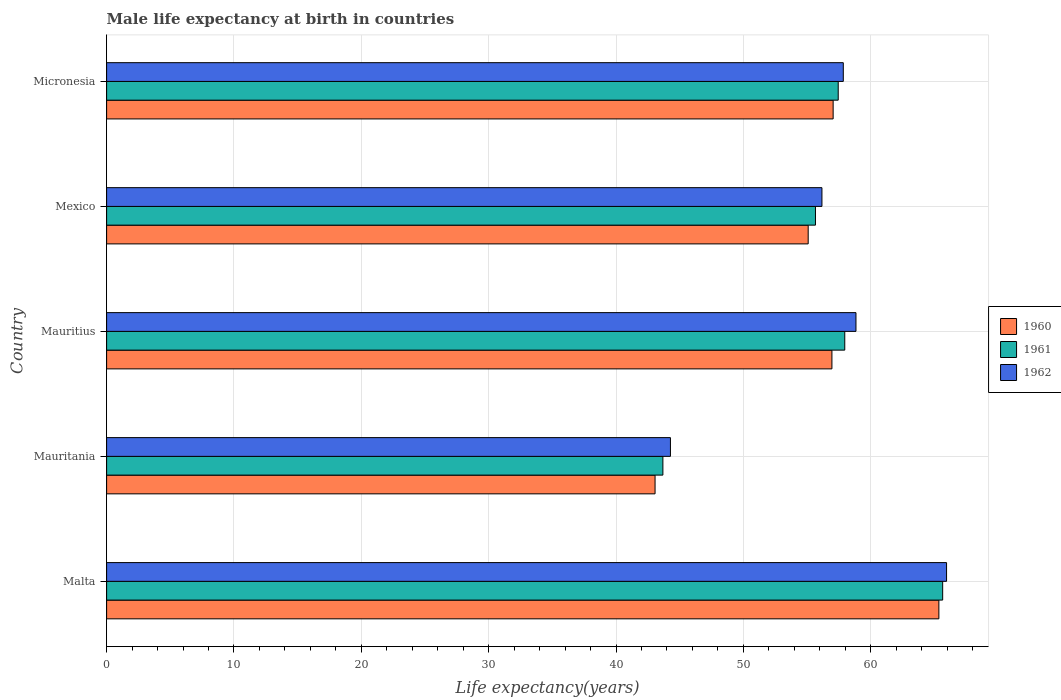How many groups of bars are there?
Ensure brevity in your answer.  5. Are the number of bars per tick equal to the number of legend labels?
Give a very brief answer. Yes. Are the number of bars on each tick of the Y-axis equal?
Your answer should be very brief. Yes. How many bars are there on the 4th tick from the top?
Your answer should be very brief. 3. What is the label of the 2nd group of bars from the top?
Ensure brevity in your answer.  Mexico. In how many cases, is the number of bars for a given country not equal to the number of legend labels?
Offer a terse response. 0. What is the male life expectancy at birth in 1962 in Mauritius?
Your response must be concise. 58.84. Across all countries, what is the maximum male life expectancy at birth in 1960?
Make the answer very short. 65.35. Across all countries, what is the minimum male life expectancy at birth in 1960?
Offer a terse response. 43.07. In which country was the male life expectancy at birth in 1962 maximum?
Provide a short and direct response. Malta. In which country was the male life expectancy at birth in 1961 minimum?
Your answer should be compact. Mauritania. What is the total male life expectancy at birth in 1962 in the graph?
Give a very brief answer. 283.09. What is the difference between the male life expectancy at birth in 1960 in Mauritius and that in Mexico?
Make the answer very short. 1.86. What is the difference between the male life expectancy at birth in 1962 in Mauritania and the male life expectancy at birth in 1960 in Malta?
Ensure brevity in your answer.  -21.08. What is the average male life expectancy at birth in 1960 per country?
Provide a short and direct response. 55.5. What is the difference between the male life expectancy at birth in 1961 and male life expectancy at birth in 1960 in Mexico?
Provide a short and direct response. 0.57. What is the ratio of the male life expectancy at birth in 1961 in Mauritius to that in Mexico?
Keep it short and to the point. 1.04. What is the difference between the highest and the second highest male life expectancy at birth in 1962?
Offer a terse response. 7.11. What is the difference between the highest and the lowest male life expectancy at birth in 1961?
Give a very brief answer. 21.97. In how many countries, is the male life expectancy at birth in 1962 greater than the average male life expectancy at birth in 1962 taken over all countries?
Offer a very short reply. 3. Is the sum of the male life expectancy at birth in 1961 in Mauritius and Mexico greater than the maximum male life expectancy at birth in 1962 across all countries?
Make the answer very short. Yes. How many bars are there?
Your answer should be very brief. 15. What is the difference between two consecutive major ticks on the X-axis?
Offer a terse response. 10. Where does the legend appear in the graph?
Provide a succinct answer. Center right. How are the legend labels stacked?
Provide a short and direct response. Vertical. What is the title of the graph?
Give a very brief answer. Male life expectancy at birth in countries. Does "1969" appear as one of the legend labels in the graph?
Ensure brevity in your answer.  No. What is the label or title of the X-axis?
Keep it short and to the point. Life expectancy(years). What is the label or title of the Y-axis?
Ensure brevity in your answer.  Country. What is the Life expectancy(years) of 1960 in Malta?
Offer a terse response. 65.35. What is the Life expectancy(years) of 1961 in Malta?
Give a very brief answer. 65.65. What is the Life expectancy(years) in 1962 in Malta?
Your answer should be compact. 65.96. What is the Life expectancy(years) of 1960 in Mauritania?
Your response must be concise. 43.07. What is the Life expectancy(years) in 1961 in Mauritania?
Give a very brief answer. 43.68. What is the Life expectancy(years) in 1962 in Mauritania?
Ensure brevity in your answer.  44.27. What is the Life expectancy(years) in 1960 in Mauritius?
Offer a very short reply. 56.95. What is the Life expectancy(years) of 1961 in Mauritius?
Offer a very short reply. 57.96. What is the Life expectancy(years) of 1962 in Mauritius?
Your response must be concise. 58.84. What is the Life expectancy(years) in 1960 in Mexico?
Your answer should be very brief. 55.09. What is the Life expectancy(years) of 1961 in Mexico?
Keep it short and to the point. 55.66. What is the Life expectancy(years) of 1962 in Mexico?
Your answer should be compact. 56.17. What is the Life expectancy(years) of 1960 in Micronesia?
Provide a short and direct response. 57.05. What is the Life expectancy(years) in 1961 in Micronesia?
Ensure brevity in your answer.  57.45. What is the Life expectancy(years) of 1962 in Micronesia?
Offer a very short reply. 57.85. Across all countries, what is the maximum Life expectancy(years) in 1960?
Offer a terse response. 65.35. Across all countries, what is the maximum Life expectancy(years) in 1961?
Offer a terse response. 65.65. Across all countries, what is the maximum Life expectancy(years) of 1962?
Your response must be concise. 65.96. Across all countries, what is the minimum Life expectancy(years) of 1960?
Give a very brief answer. 43.07. Across all countries, what is the minimum Life expectancy(years) in 1961?
Provide a succinct answer. 43.68. Across all countries, what is the minimum Life expectancy(years) of 1962?
Keep it short and to the point. 44.27. What is the total Life expectancy(years) in 1960 in the graph?
Keep it short and to the point. 277.51. What is the total Life expectancy(years) of 1961 in the graph?
Keep it short and to the point. 280.41. What is the total Life expectancy(years) of 1962 in the graph?
Your response must be concise. 283.09. What is the difference between the Life expectancy(years) of 1960 in Malta and that in Mauritania?
Give a very brief answer. 22.29. What is the difference between the Life expectancy(years) of 1961 in Malta and that in Mauritania?
Ensure brevity in your answer.  21.97. What is the difference between the Life expectancy(years) in 1962 in Malta and that in Mauritania?
Offer a terse response. 21.68. What is the difference between the Life expectancy(years) of 1960 in Malta and that in Mauritius?
Offer a terse response. 8.4. What is the difference between the Life expectancy(years) of 1961 in Malta and that in Mauritius?
Make the answer very short. 7.69. What is the difference between the Life expectancy(years) of 1962 in Malta and that in Mauritius?
Ensure brevity in your answer.  7.11. What is the difference between the Life expectancy(years) in 1960 in Malta and that in Mexico?
Your answer should be very brief. 10.26. What is the difference between the Life expectancy(years) in 1961 in Malta and that in Mexico?
Give a very brief answer. 9.99. What is the difference between the Life expectancy(years) of 1962 in Malta and that in Mexico?
Your response must be concise. 9.79. What is the difference between the Life expectancy(years) in 1960 in Malta and that in Micronesia?
Provide a short and direct response. 8.3. What is the difference between the Life expectancy(years) in 1961 in Malta and that in Micronesia?
Your answer should be very brief. 8.2. What is the difference between the Life expectancy(years) of 1962 in Malta and that in Micronesia?
Provide a succinct answer. 8.11. What is the difference between the Life expectancy(years) in 1960 in Mauritania and that in Mauritius?
Make the answer very short. -13.89. What is the difference between the Life expectancy(years) of 1961 in Mauritania and that in Mauritius?
Provide a short and direct response. -14.28. What is the difference between the Life expectancy(years) of 1962 in Mauritania and that in Mauritius?
Offer a very short reply. -14.57. What is the difference between the Life expectancy(years) of 1960 in Mauritania and that in Mexico?
Your response must be concise. -12.02. What is the difference between the Life expectancy(years) of 1961 in Mauritania and that in Mexico?
Keep it short and to the point. -11.98. What is the difference between the Life expectancy(years) in 1962 in Mauritania and that in Mexico?
Offer a terse response. -11.9. What is the difference between the Life expectancy(years) in 1960 in Mauritania and that in Micronesia?
Provide a succinct answer. -13.98. What is the difference between the Life expectancy(years) in 1961 in Mauritania and that in Micronesia?
Ensure brevity in your answer.  -13.77. What is the difference between the Life expectancy(years) in 1962 in Mauritania and that in Micronesia?
Your answer should be compact. -13.57. What is the difference between the Life expectancy(years) in 1960 in Mauritius and that in Mexico?
Keep it short and to the point. 1.86. What is the difference between the Life expectancy(years) of 1961 in Mauritius and that in Mexico?
Give a very brief answer. 2.3. What is the difference between the Life expectancy(years) of 1962 in Mauritius and that in Mexico?
Offer a terse response. 2.67. What is the difference between the Life expectancy(years) of 1960 in Mauritius and that in Micronesia?
Provide a short and direct response. -0.1. What is the difference between the Life expectancy(years) in 1961 in Mauritius and that in Micronesia?
Your answer should be compact. 0.51. What is the difference between the Life expectancy(years) of 1962 in Mauritius and that in Micronesia?
Make the answer very short. 1. What is the difference between the Life expectancy(years) of 1960 in Mexico and that in Micronesia?
Provide a succinct answer. -1.96. What is the difference between the Life expectancy(years) in 1961 in Mexico and that in Micronesia?
Ensure brevity in your answer.  -1.79. What is the difference between the Life expectancy(years) of 1962 in Mexico and that in Micronesia?
Offer a terse response. -1.68. What is the difference between the Life expectancy(years) in 1960 in Malta and the Life expectancy(years) in 1961 in Mauritania?
Provide a succinct answer. 21.67. What is the difference between the Life expectancy(years) in 1960 in Malta and the Life expectancy(years) in 1962 in Mauritania?
Make the answer very short. 21.08. What is the difference between the Life expectancy(years) in 1961 in Malta and the Life expectancy(years) in 1962 in Mauritania?
Your answer should be compact. 21.38. What is the difference between the Life expectancy(years) of 1960 in Malta and the Life expectancy(years) of 1961 in Mauritius?
Your response must be concise. 7.39. What is the difference between the Life expectancy(years) of 1960 in Malta and the Life expectancy(years) of 1962 in Mauritius?
Make the answer very short. 6.51. What is the difference between the Life expectancy(years) in 1961 in Malta and the Life expectancy(years) in 1962 in Mauritius?
Ensure brevity in your answer.  6.81. What is the difference between the Life expectancy(years) of 1960 in Malta and the Life expectancy(years) of 1961 in Mexico?
Provide a short and direct response. 9.69. What is the difference between the Life expectancy(years) in 1960 in Malta and the Life expectancy(years) in 1962 in Mexico?
Ensure brevity in your answer.  9.18. What is the difference between the Life expectancy(years) of 1961 in Malta and the Life expectancy(years) of 1962 in Mexico?
Give a very brief answer. 9.48. What is the difference between the Life expectancy(years) in 1960 in Malta and the Life expectancy(years) in 1961 in Micronesia?
Ensure brevity in your answer.  7.9. What is the difference between the Life expectancy(years) of 1960 in Malta and the Life expectancy(years) of 1962 in Micronesia?
Your answer should be compact. 7.51. What is the difference between the Life expectancy(years) of 1961 in Malta and the Life expectancy(years) of 1962 in Micronesia?
Provide a short and direct response. 7.8. What is the difference between the Life expectancy(years) of 1960 in Mauritania and the Life expectancy(years) of 1961 in Mauritius?
Your response must be concise. -14.9. What is the difference between the Life expectancy(years) in 1960 in Mauritania and the Life expectancy(years) in 1962 in Mauritius?
Ensure brevity in your answer.  -15.78. What is the difference between the Life expectancy(years) in 1961 in Mauritania and the Life expectancy(years) in 1962 in Mauritius?
Keep it short and to the point. -15.16. What is the difference between the Life expectancy(years) of 1960 in Mauritania and the Life expectancy(years) of 1961 in Mexico?
Offer a terse response. -12.6. What is the difference between the Life expectancy(years) of 1960 in Mauritania and the Life expectancy(years) of 1962 in Mexico?
Your answer should be very brief. -13.1. What is the difference between the Life expectancy(years) in 1961 in Mauritania and the Life expectancy(years) in 1962 in Mexico?
Provide a short and direct response. -12.49. What is the difference between the Life expectancy(years) in 1960 in Mauritania and the Life expectancy(years) in 1961 in Micronesia?
Offer a terse response. -14.38. What is the difference between the Life expectancy(years) in 1960 in Mauritania and the Life expectancy(years) in 1962 in Micronesia?
Make the answer very short. -14.78. What is the difference between the Life expectancy(years) of 1961 in Mauritania and the Life expectancy(years) of 1962 in Micronesia?
Offer a very short reply. -14.17. What is the difference between the Life expectancy(years) of 1960 in Mauritius and the Life expectancy(years) of 1961 in Mexico?
Make the answer very short. 1.29. What is the difference between the Life expectancy(years) of 1960 in Mauritius and the Life expectancy(years) of 1962 in Mexico?
Your answer should be compact. 0.78. What is the difference between the Life expectancy(years) of 1961 in Mauritius and the Life expectancy(years) of 1962 in Mexico?
Provide a short and direct response. 1.79. What is the difference between the Life expectancy(years) of 1960 in Mauritius and the Life expectancy(years) of 1961 in Micronesia?
Ensure brevity in your answer.  -0.49. What is the difference between the Life expectancy(years) of 1960 in Mauritius and the Life expectancy(years) of 1962 in Micronesia?
Provide a short and direct response. -0.89. What is the difference between the Life expectancy(years) in 1961 in Mauritius and the Life expectancy(years) in 1962 in Micronesia?
Your answer should be compact. 0.12. What is the difference between the Life expectancy(years) of 1960 in Mexico and the Life expectancy(years) of 1961 in Micronesia?
Your answer should be compact. -2.36. What is the difference between the Life expectancy(years) of 1960 in Mexico and the Life expectancy(years) of 1962 in Micronesia?
Your response must be concise. -2.76. What is the difference between the Life expectancy(years) in 1961 in Mexico and the Life expectancy(years) in 1962 in Micronesia?
Give a very brief answer. -2.19. What is the average Life expectancy(years) of 1960 per country?
Offer a very short reply. 55.5. What is the average Life expectancy(years) of 1961 per country?
Offer a terse response. 56.08. What is the average Life expectancy(years) of 1962 per country?
Provide a succinct answer. 56.62. What is the difference between the Life expectancy(years) in 1960 and Life expectancy(years) in 1961 in Malta?
Your response must be concise. -0.3. What is the difference between the Life expectancy(years) in 1960 and Life expectancy(years) in 1962 in Malta?
Offer a terse response. -0.6. What is the difference between the Life expectancy(years) of 1961 and Life expectancy(years) of 1962 in Malta?
Your answer should be very brief. -0.3. What is the difference between the Life expectancy(years) in 1960 and Life expectancy(years) in 1961 in Mauritania?
Your answer should be very brief. -0.61. What is the difference between the Life expectancy(years) of 1960 and Life expectancy(years) of 1962 in Mauritania?
Provide a short and direct response. -1.21. What is the difference between the Life expectancy(years) of 1961 and Life expectancy(years) of 1962 in Mauritania?
Make the answer very short. -0.59. What is the difference between the Life expectancy(years) of 1960 and Life expectancy(years) of 1961 in Mauritius?
Keep it short and to the point. -1.01. What is the difference between the Life expectancy(years) of 1960 and Life expectancy(years) of 1962 in Mauritius?
Give a very brief answer. -1.89. What is the difference between the Life expectancy(years) of 1961 and Life expectancy(years) of 1962 in Mauritius?
Give a very brief answer. -0.88. What is the difference between the Life expectancy(years) of 1960 and Life expectancy(years) of 1961 in Mexico?
Keep it short and to the point. -0.57. What is the difference between the Life expectancy(years) in 1960 and Life expectancy(years) in 1962 in Mexico?
Provide a short and direct response. -1.08. What is the difference between the Life expectancy(years) in 1961 and Life expectancy(years) in 1962 in Mexico?
Offer a very short reply. -0.51. What is the difference between the Life expectancy(years) of 1960 and Life expectancy(years) of 1961 in Micronesia?
Your response must be concise. -0.4. What is the difference between the Life expectancy(years) of 1960 and Life expectancy(years) of 1962 in Micronesia?
Your answer should be compact. -0.8. What is the difference between the Life expectancy(years) in 1961 and Life expectancy(years) in 1962 in Micronesia?
Your answer should be compact. -0.4. What is the ratio of the Life expectancy(years) of 1960 in Malta to that in Mauritania?
Your answer should be compact. 1.52. What is the ratio of the Life expectancy(years) of 1961 in Malta to that in Mauritania?
Your answer should be compact. 1.5. What is the ratio of the Life expectancy(years) in 1962 in Malta to that in Mauritania?
Your response must be concise. 1.49. What is the ratio of the Life expectancy(years) in 1960 in Malta to that in Mauritius?
Keep it short and to the point. 1.15. What is the ratio of the Life expectancy(years) in 1961 in Malta to that in Mauritius?
Your answer should be very brief. 1.13. What is the ratio of the Life expectancy(years) of 1962 in Malta to that in Mauritius?
Provide a succinct answer. 1.12. What is the ratio of the Life expectancy(years) in 1960 in Malta to that in Mexico?
Offer a terse response. 1.19. What is the ratio of the Life expectancy(years) in 1961 in Malta to that in Mexico?
Your answer should be compact. 1.18. What is the ratio of the Life expectancy(years) of 1962 in Malta to that in Mexico?
Offer a very short reply. 1.17. What is the ratio of the Life expectancy(years) of 1960 in Malta to that in Micronesia?
Ensure brevity in your answer.  1.15. What is the ratio of the Life expectancy(years) of 1961 in Malta to that in Micronesia?
Offer a terse response. 1.14. What is the ratio of the Life expectancy(years) of 1962 in Malta to that in Micronesia?
Provide a short and direct response. 1.14. What is the ratio of the Life expectancy(years) in 1960 in Mauritania to that in Mauritius?
Your response must be concise. 0.76. What is the ratio of the Life expectancy(years) of 1961 in Mauritania to that in Mauritius?
Ensure brevity in your answer.  0.75. What is the ratio of the Life expectancy(years) of 1962 in Mauritania to that in Mauritius?
Your response must be concise. 0.75. What is the ratio of the Life expectancy(years) in 1960 in Mauritania to that in Mexico?
Provide a short and direct response. 0.78. What is the ratio of the Life expectancy(years) of 1961 in Mauritania to that in Mexico?
Offer a terse response. 0.78. What is the ratio of the Life expectancy(years) of 1962 in Mauritania to that in Mexico?
Your answer should be very brief. 0.79. What is the ratio of the Life expectancy(years) in 1960 in Mauritania to that in Micronesia?
Give a very brief answer. 0.75. What is the ratio of the Life expectancy(years) in 1961 in Mauritania to that in Micronesia?
Give a very brief answer. 0.76. What is the ratio of the Life expectancy(years) in 1962 in Mauritania to that in Micronesia?
Offer a terse response. 0.77. What is the ratio of the Life expectancy(years) of 1960 in Mauritius to that in Mexico?
Offer a terse response. 1.03. What is the ratio of the Life expectancy(years) of 1961 in Mauritius to that in Mexico?
Your answer should be compact. 1.04. What is the ratio of the Life expectancy(years) in 1962 in Mauritius to that in Mexico?
Make the answer very short. 1.05. What is the ratio of the Life expectancy(years) of 1960 in Mauritius to that in Micronesia?
Offer a terse response. 1. What is the ratio of the Life expectancy(years) of 1961 in Mauritius to that in Micronesia?
Make the answer very short. 1.01. What is the ratio of the Life expectancy(years) of 1962 in Mauritius to that in Micronesia?
Your response must be concise. 1.02. What is the ratio of the Life expectancy(years) in 1960 in Mexico to that in Micronesia?
Give a very brief answer. 0.97. What is the ratio of the Life expectancy(years) in 1961 in Mexico to that in Micronesia?
Provide a succinct answer. 0.97. What is the difference between the highest and the second highest Life expectancy(years) in 1960?
Keep it short and to the point. 8.3. What is the difference between the highest and the second highest Life expectancy(years) of 1961?
Offer a very short reply. 7.69. What is the difference between the highest and the second highest Life expectancy(years) in 1962?
Provide a short and direct response. 7.11. What is the difference between the highest and the lowest Life expectancy(years) of 1960?
Make the answer very short. 22.29. What is the difference between the highest and the lowest Life expectancy(years) of 1961?
Your answer should be compact. 21.97. What is the difference between the highest and the lowest Life expectancy(years) in 1962?
Your response must be concise. 21.68. 